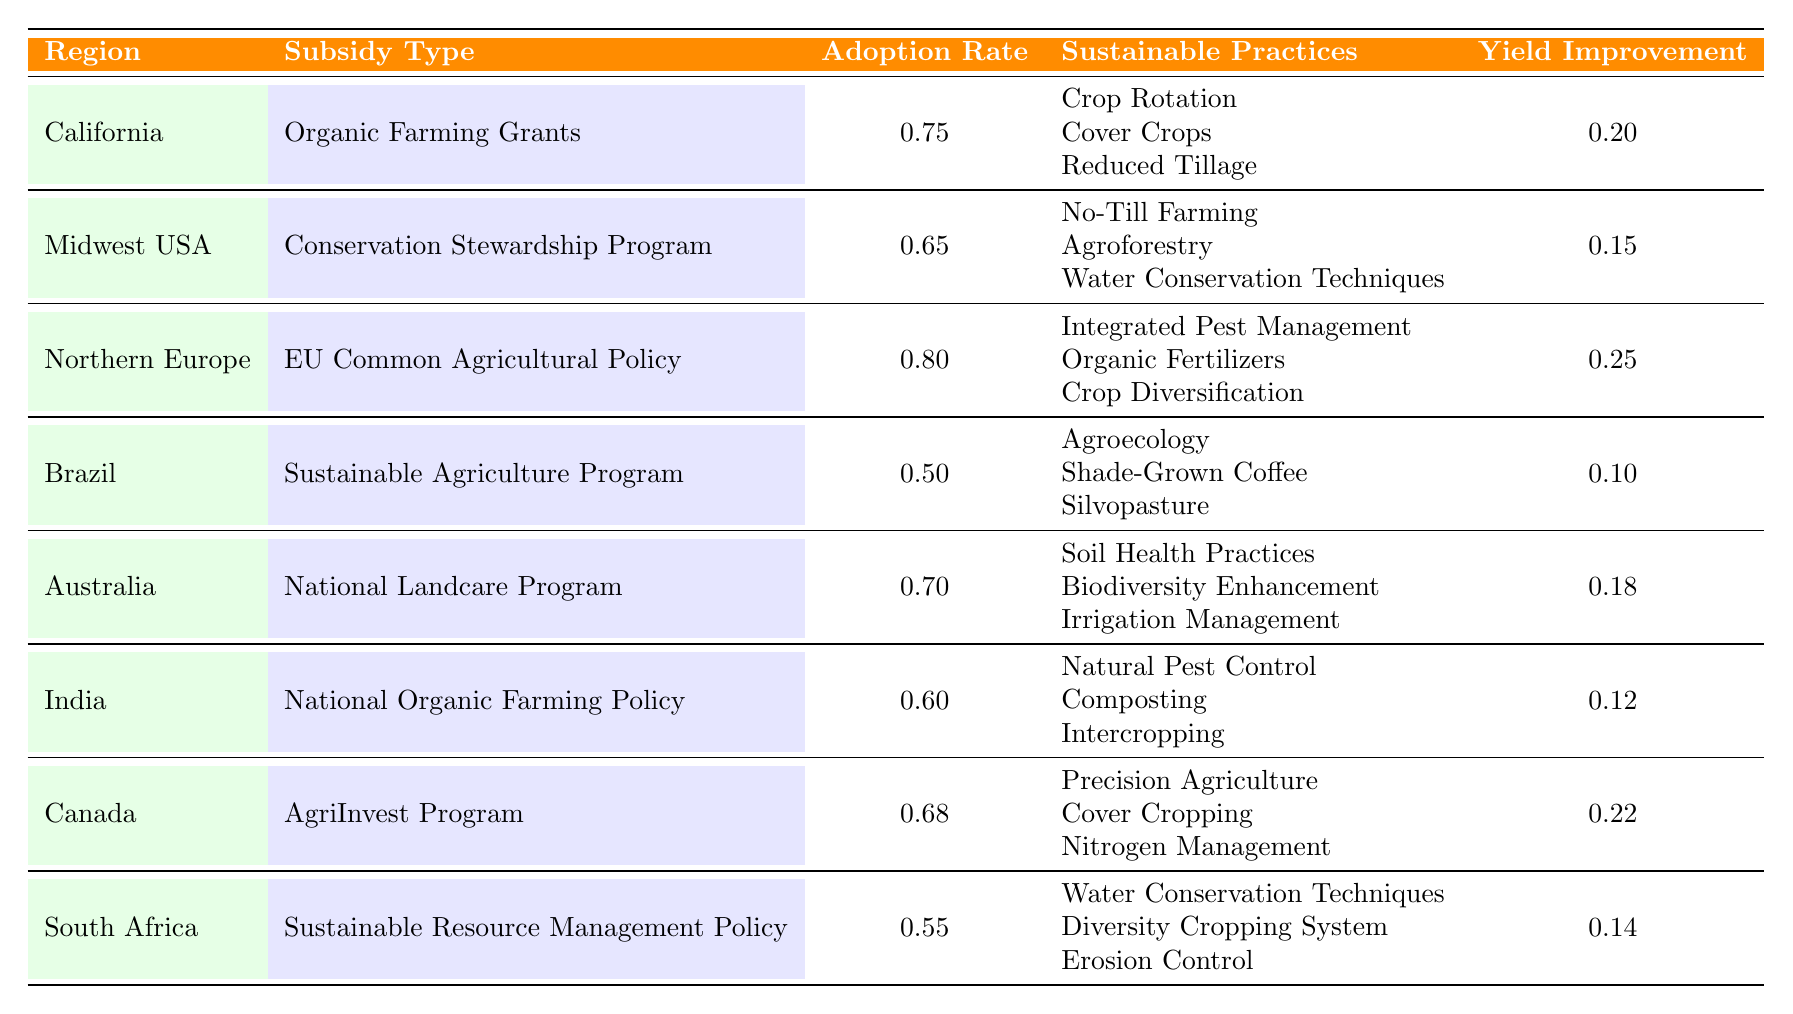What is the highest adoption rate for sustainable practices? By reviewing the "Adoption Rate" column, we see three regions recorded adoption rates. "California" has an adoption rate of 0.75, "Northern Europe" has 0.80, and "Canada" has 0.68. The highest among these is "Northern Europe" at 0.80.
Answer: 0.80 Which region has the lowest yield improvement? In the "Yield Improvement" column, we compare the values: California (0.20), Midwest USA (0.15), Northern Europe (0.25), Brazil (0.10), Australia (0.18), India (0.12), Canada (0.22), and South Africa (0.14). The lowest value is from "Brazil," which is 0.10.
Answer: 0.10 Is the adoption rate in Australia higher than in India? Comparing the adoption rates, Australia has 0.70 and India has 0.60. Since 0.70 is greater than 0.60, it confirms that Australia has a higher adoption rate than India.
Answer: Yes What is the total yield improvement for regions with an adoption rate above 0.65? The regions meeting this criteria are California (0.20), Northern Europe (0.25), and Canada (0.22). We sum these values: 0.20 + 0.25 + 0.22 = 0.67.
Answer: 0.67 Which sustainable practice is common in the greatest number of regions listed? Analyzing the "Sustainable Practices" entries for each region, we note practices mentioned in multiple regions. "Water Conservation Techniques" appears in the Midwest USA and South Africa, "Cover Crops" appears in California and Canada, while others are unique. Thus, both "Water Conservation Techniques" and "Cover Crops" are common in 2 regions.
Answer: Water Conservation Techniques and Cover Crops What is the average adoption rate across all regions? To find the average, sum the adoption rates: 0.75 + 0.65 + 0.80 + 0.50 + 0.70 + 0.60 + 0.68 + 0.55 = 5.73. There are 8 regions, so the average is 5.73 / 8 = 0.71625, which rounds to 0.72.
Answer: 0.72 Is Brazil's adoption rate lower than South Africa's? Brazil's adoption rate is 0.50 and South Africa's is 0.55. Since 0.50 is less than 0.55, it confirms that Brazil's adoption rate is indeed lower.
Answer: Yes Which region shows the highest yield improvement from sustainable practices? Looking at the "Yield Improvement" column values, we see the following: California (0.20), Midwest USA (0.15), Northern Europe (0.25), Brazil (0.10), Australia (0.18), India (0.12), Canada (0.22), and South Africa (0.14). The highest value belongs to "Northern Europe" at 0.25.
Answer: Northern Europe 